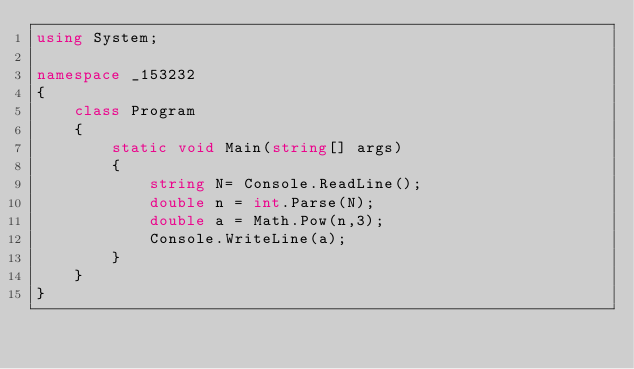<code> <loc_0><loc_0><loc_500><loc_500><_C#_>using System;

namespace _153232
{
    class Program
    {
        static void Main(string[] args)
        {
            string N= Console.ReadLine();
            double n = int.Parse(N);
            double a = Math.Pow(n,3);
            Console.WriteLine(a);
        }
    }
}
</code> 